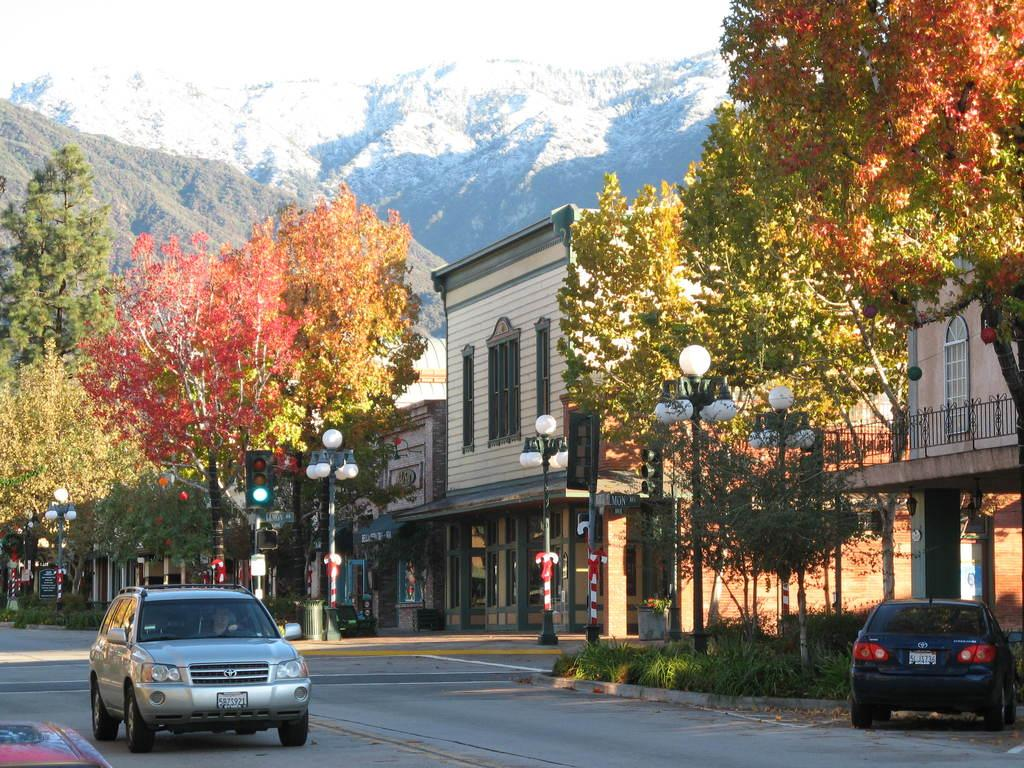What type of vehicles can be seen on the road in the image? There are cars on the road in the image. What structures are visible in the image? There are buildings visible in the image. What type of vegetation is present in the image? Trees are present in the image. What type of poles can be seen in the image? There are poles and traffic poles visible in the image. What type of lights are present in the image? There are lights in the image. What can be seen in the background of the image? There are hills and the sky visible in the background of the image. Can you tell me how many cherries are on the page in the image? There is no page or cherries present in the image. What type of tool is being used to fix the car in the image? There is no tool being used to fix a car in the image; it only shows cars on the road. 